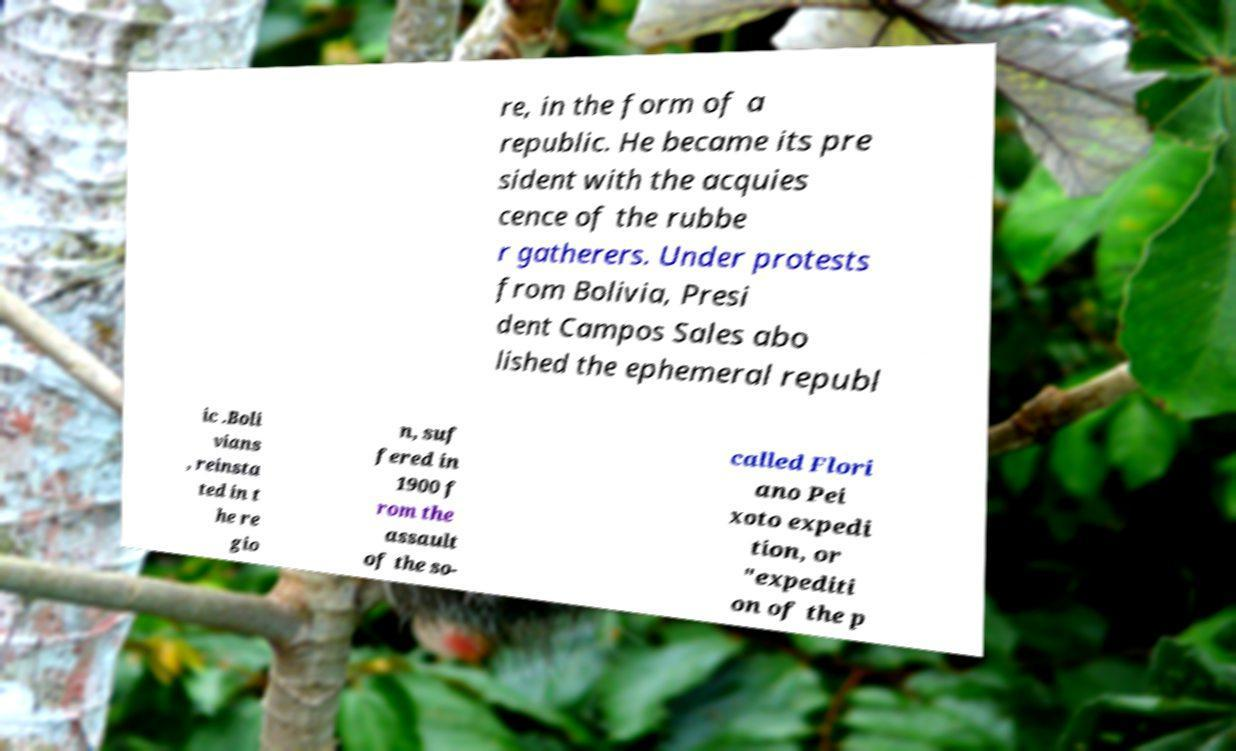For documentation purposes, I need the text within this image transcribed. Could you provide that? re, in the form of a republic. He became its pre sident with the acquies cence of the rubbe r gatherers. Under protests from Bolivia, Presi dent Campos Sales abo lished the ephemeral republ ic .Boli vians , reinsta ted in t he re gio n, suf fered in 1900 f rom the assault of the so- called Flori ano Pei xoto expedi tion, or "expediti on of the p 